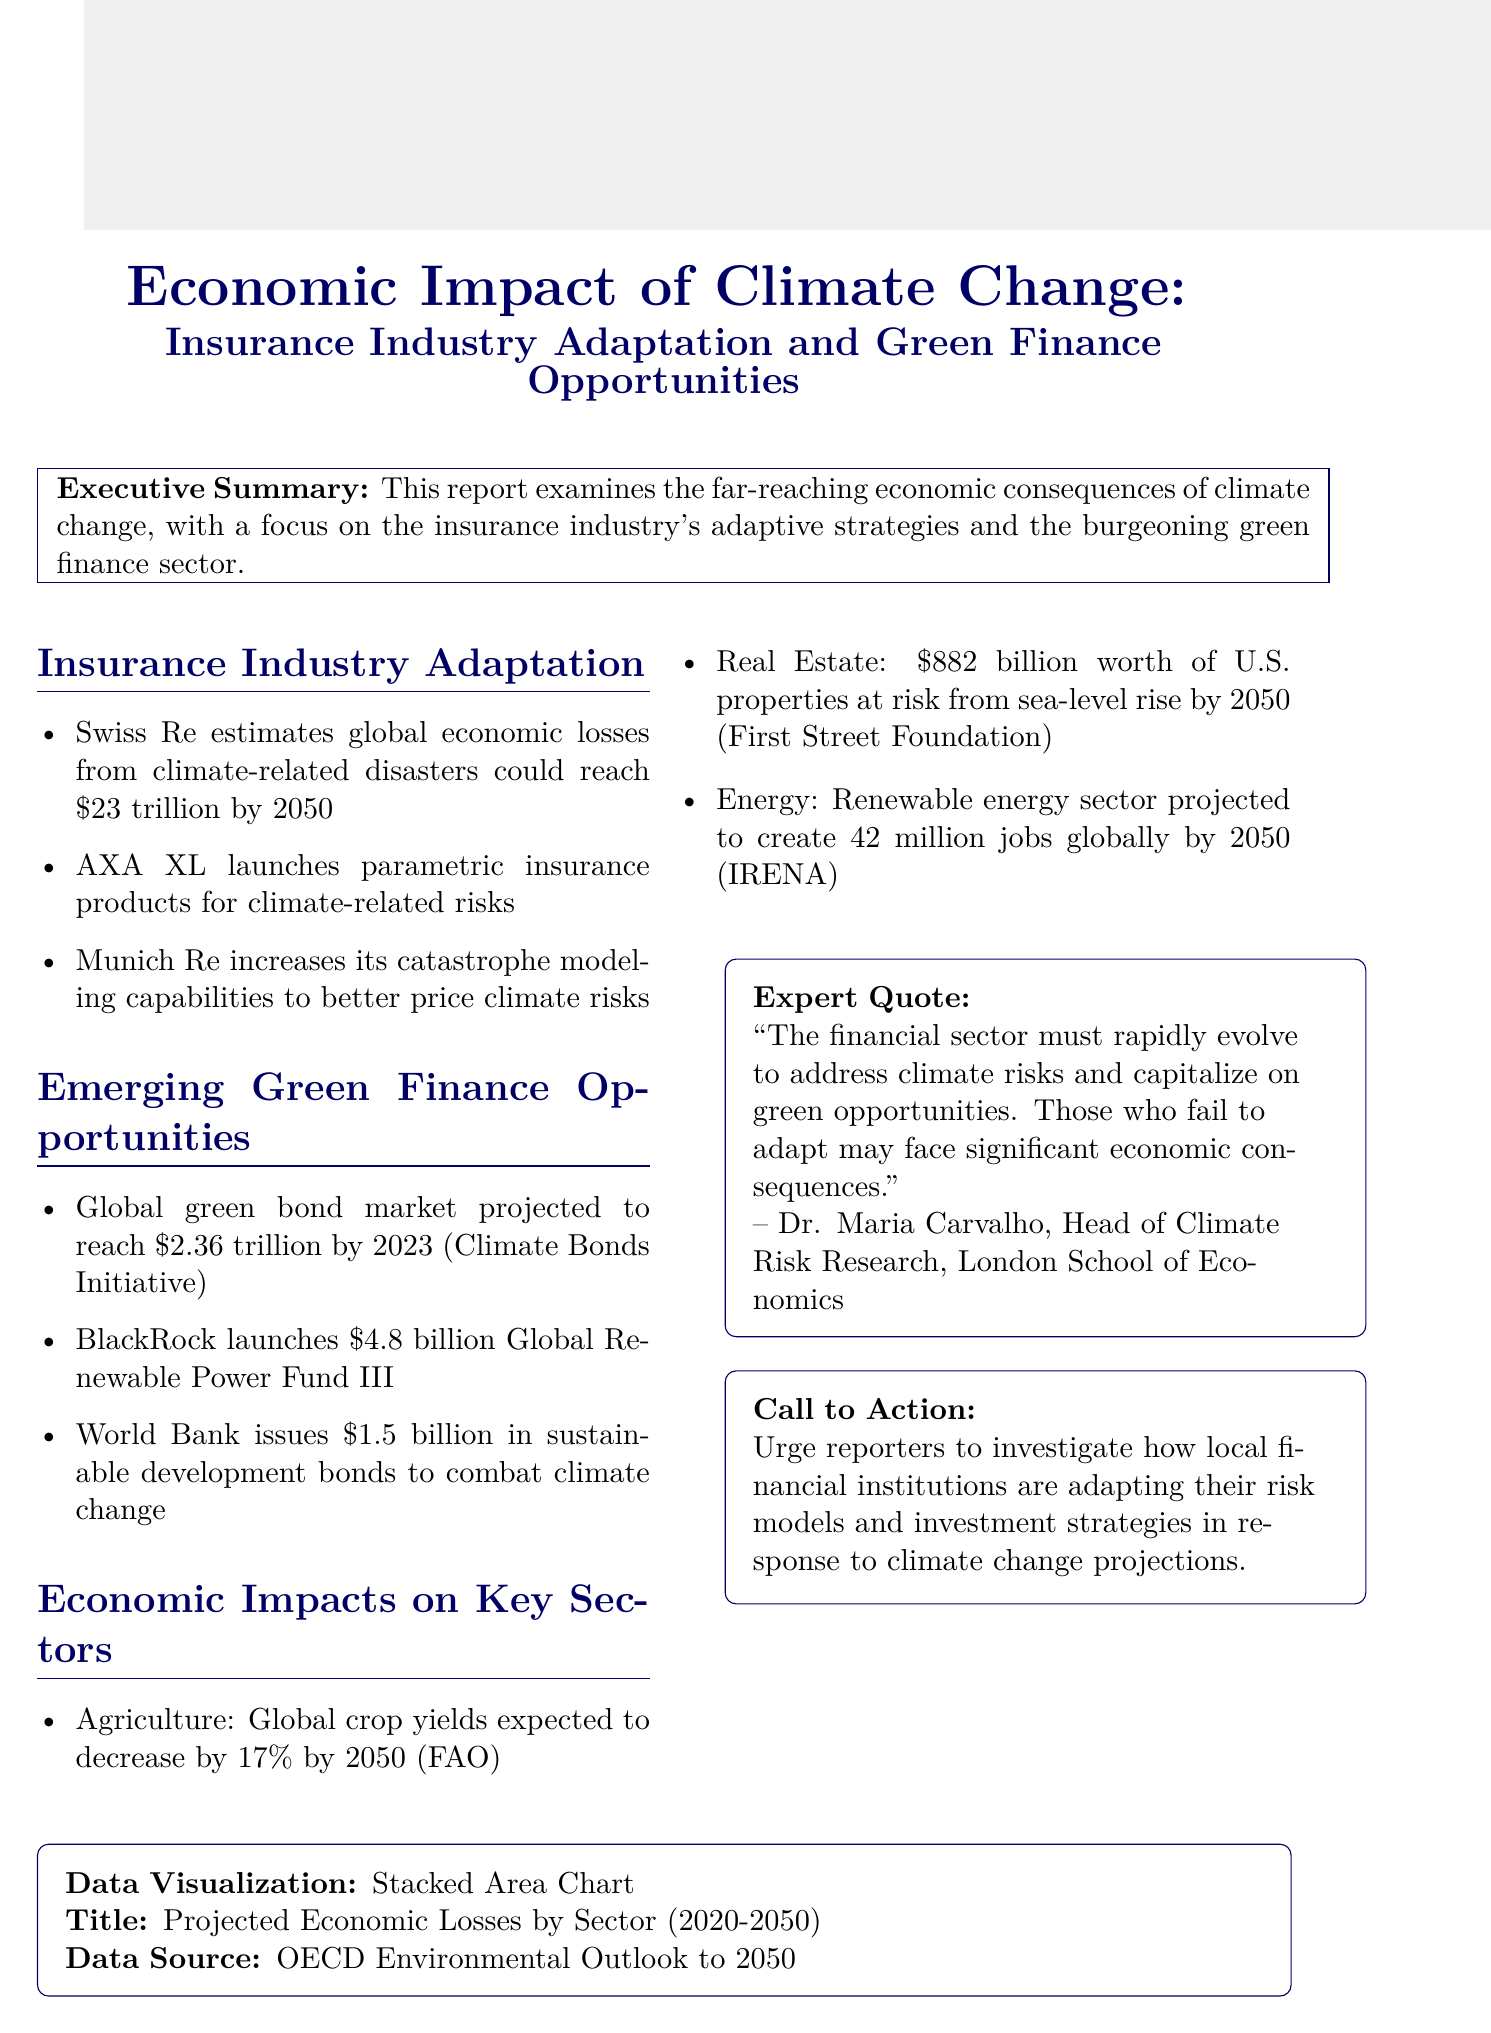What are the projected global economic losses from climate-related disasters by 2050? The document states that Swiss Re estimates global economic losses from climate-related disasters could reach $23 trillion by 2050.
Answer: $23 trillion Which company launched parametric insurance products for climate-related risks? The document identifies AXA XL as the company that launched parametric insurance products for climate-related risks.
Answer: AXA XL What is the projected size of the global green bond market by 2023? According to the Climate Bonds Initiative, the global green bond market is projected to reach $2.36 trillion by 2023.
Answer: $2.36 trillion How much is BlackRock's Global Renewable Power Fund III worth? The document reports that BlackRock has launched a $4.8 billion Global Renewable Power Fund III.
Answer: $4.8 billion What is the expected decrease in global crop yields by 2050? The report states that global crop yields are expected to decrease by 17% by 2050 according to the FAO.
Answer: 17% Who is the head of Climate Risk Research at the London School of Economics? The document quotes Dr. Maria Carvalho, who is the head of Climate Risk Research at the London School of Economics.
Answer: Dr. Maria Carvalho What is the title of the data visualization provided in the document? The title of the data visualization mentioned in the document is "Projected Economic Losses by Sector (2020-2050)."
Answer: Projected Economic Losses by Sector (2020-2050) What is the call to action for reporters in this report? The call to action urges reporters to investigate how local financial institutions are adapting their risk models and investment strategies in response to climate change projections.
Answer: Investigate local financial institutions' adaptations to climate change What is the projected number of jobs in the renewable energy sector by 2050? The document indicates that the renewable energy sector is projected to create 42 million jobs globally by 2050, according to IRENA.
Answer: 42 million jobs 